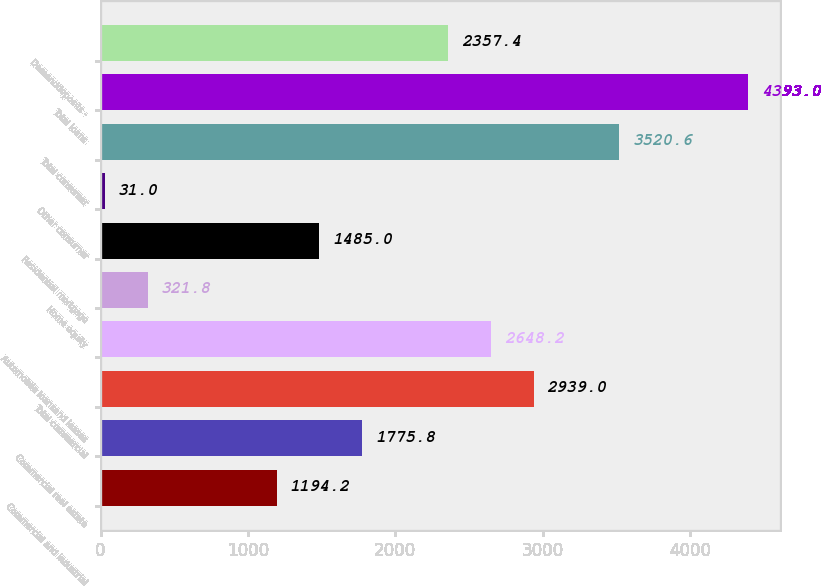Convert chart to OTSL. <chart><loc_0><loc_0><loc_500><loc_500><bar_chart><fcel>Commercial and industrial<fcel>Commercial real estate<fcel>Total commercial<fcel>Automobile loansand leases<fcel>Home equity<fcel>Residential mortgage<fcel>Other consumer<fcel>Total consumer<fcel>Total loans<fcel>Demanddeposits -<nl><fcel>1194.2<fcel>1775.8<fcel>2939<fcel>2648.2<fcel>321.8<fcel>1485<fcel>31<fcel>3520.6<fcel>4393<fcel>2357.4<nl></chart> 